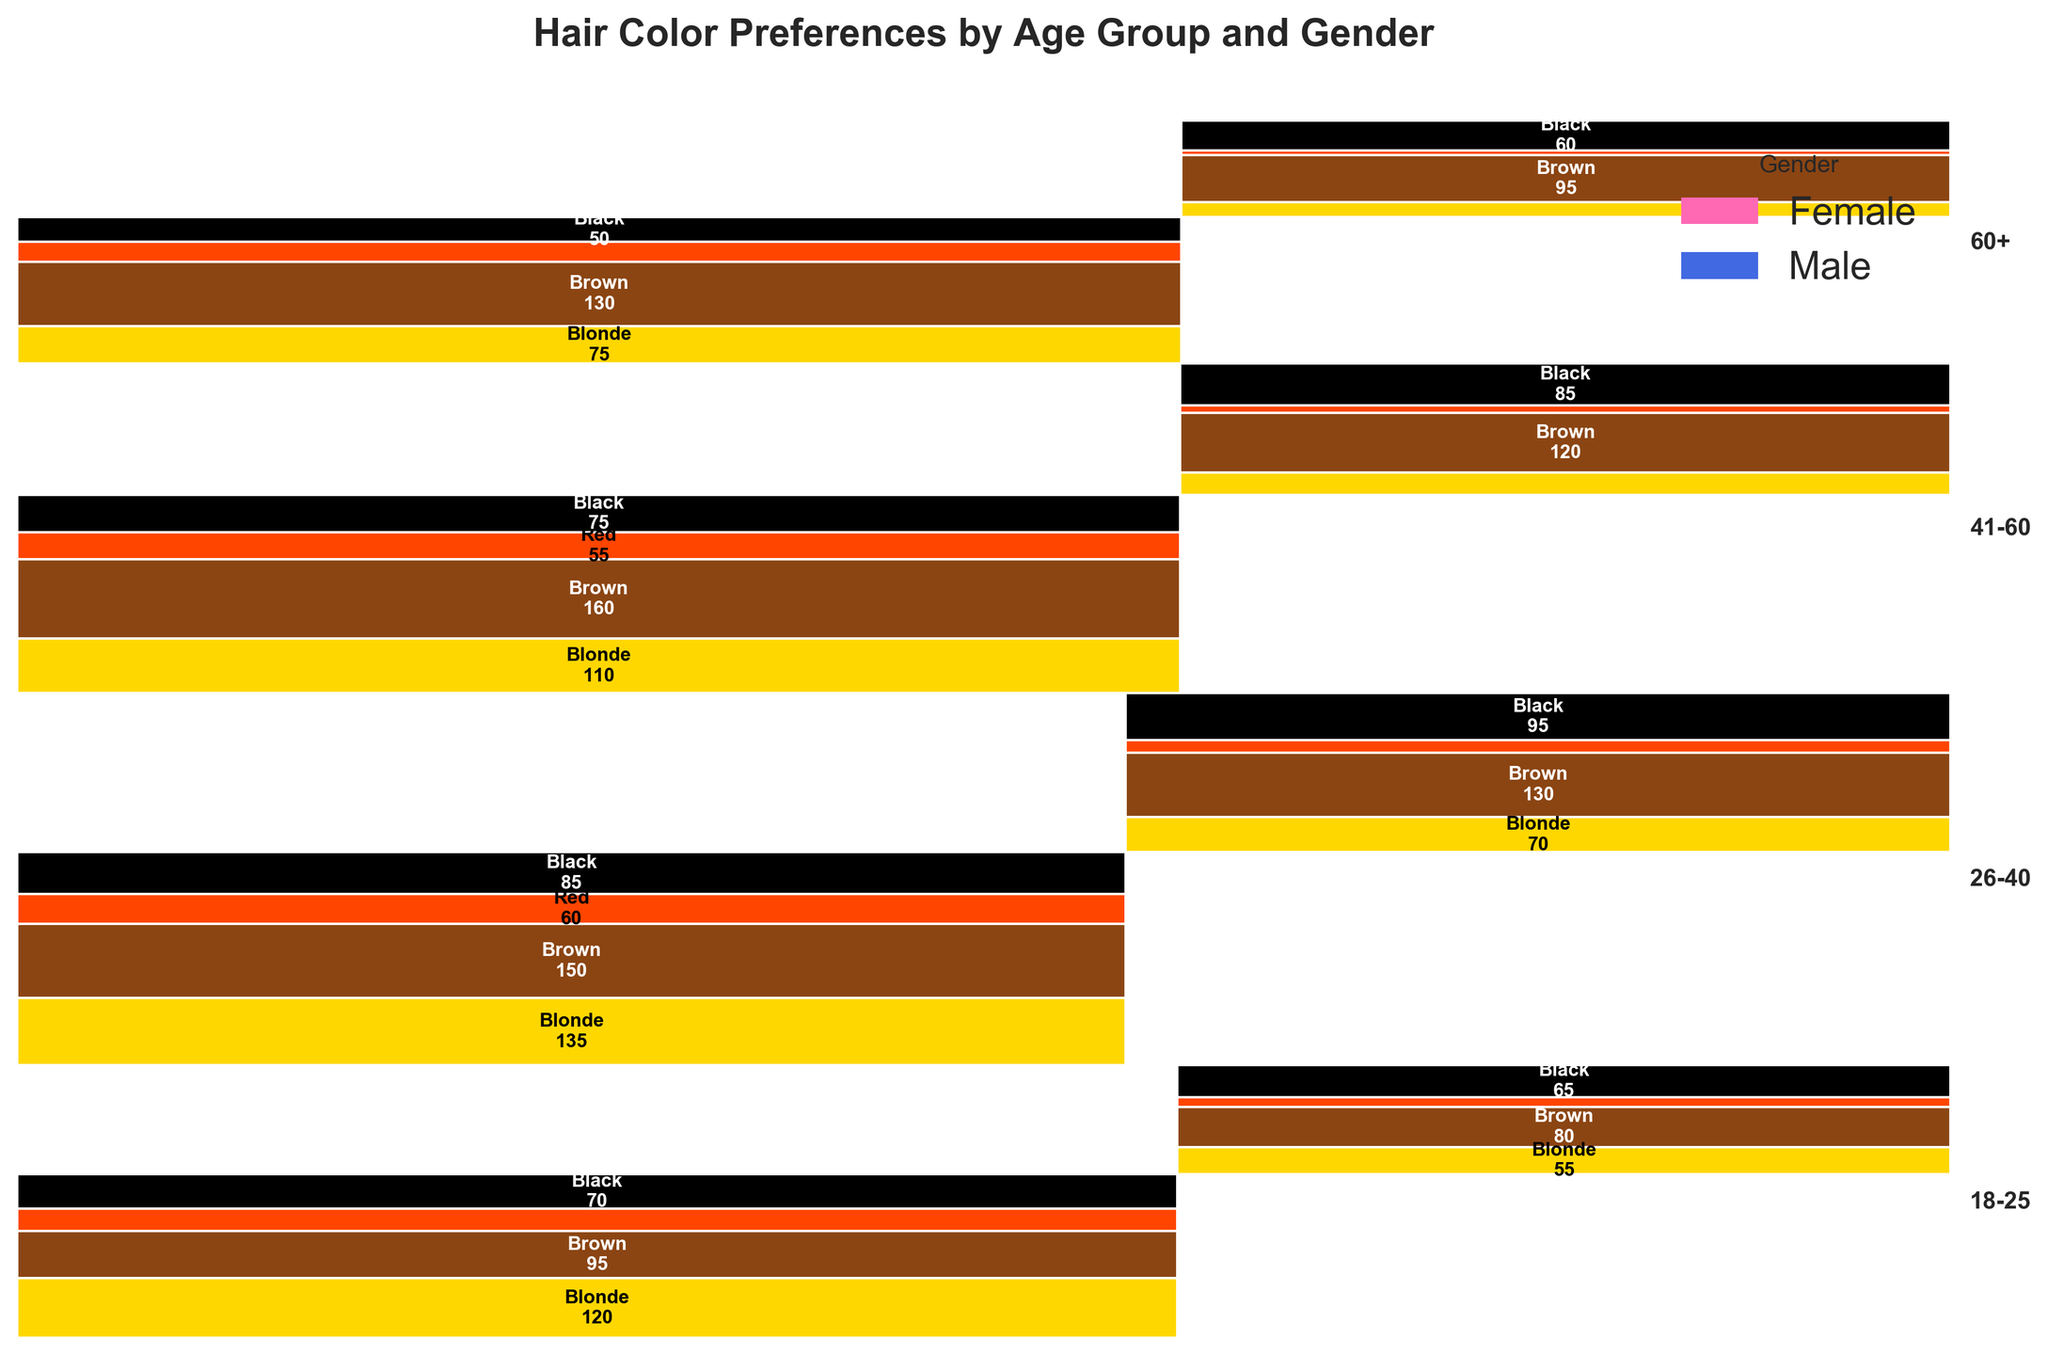What is the title of the mosaic plot? The title is usually prominently displayed at the top of the plot. In this case, the title is written directly in the code: "Hair Color Preferences by Age Group and Gender".
Answer: Hair Color Preferences by Age Group and Gender How many age groups are represented in the mosaic plot? The mosaic plot groups the data by distinct age ranges. By identifying the unique age ranges used in the plot, we can count the number of groups. Here, they are: 18-25, 26-40, 41-60, and 60+.
Answer: 4 Which gender has the highest preference for blonde hair in the 26-40 age group? By observing the colors and corresponding counts in the 26-40 age group section of the plot, we look for blonde hair. The corresponding counts for each gender are compared.
Answer: Female In the 41-60 age group, which hair color is most preferred by males? Focus on the segment labeled 41-60 for males, and identify the color with the largest rectangle, which corresponds to the highest count.
Answer: Brown Which age group has the lowest preference for red hair among males? Examine each age group section for males and look at the height (relative proportions) of red hair segments; the smallest segment indicates the lowest preference.
Answer: 60+ Compare the preference for brown hair between males and females in the 18-25 age group. Which gender has a higher preference? Evaluate the size of the brown hair-colored rectangles in the 18-25 age group section for both genders and compare them.
Answer: Female In the plot, what hair color is represented by the smallest segment overall? Identify the smallest rectangle across the entire mosaic plot to determine the hair color it represents, which corresponds to the smallest count.
Answer: Red (Male, 41-60) What is the total count of individuals in the 26-40 age group? Add the counts of all hair colors for both genders in the 26-40 age group. For females: (135 + 150 + 60 + 85 = 430), and for males: (70 + 130 + 25 + 95 = 320). Add both to get the total count.
Answer: 750 Among all age groups, which age group's males have the highest collective preference for black hair? For each age group, determine the total count of black-haired males by looking at the respective segments. Compare the counts to find the highest.
Answer: 26-40 Which gender appears to have a higher preference for lighter hair colors (Blonde/Brown) in the 60+ age group? Observe and compare the combined sizes of blonde and brown segments within the 60+ age group for both genders and identify the larger one.
Answer: Female 